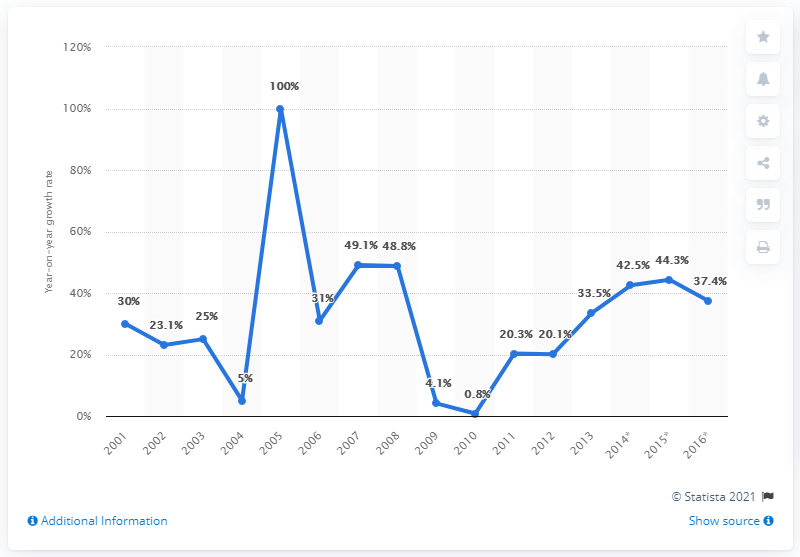Mention a couple of crucial points in this snapshot. In 2007, local digital advertising spending experienced a growth rate of 48.8%. The growth of local digital advertising spending in the U.S. was first measured in 2001. 